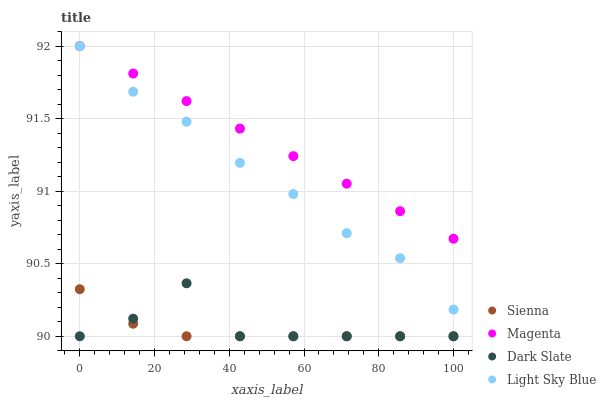Does Sienna have the minimum area under the curve?
Answer yes or no. Yes. Does Magenta have the maximum area under the curve?
Answer yes or no. Yes. Does Dark Slate have the minimum area under the curve?
Answer yes or no. No. Does Dark Slate have the maximum area under the curve?
Answer yes or no. No. Is Magenta the smoothest?
Answer yes or no. Yes. Is Dark Slate the roughest?
Answer yes or no. Yes. Is Dark Slate the smoothest?
Answer yes or no. No. Is Magenta the roughest?
Answer yes or no. No. Does Sienna have the lowest value?
Answer yes or no. Yes. Does Magenta have the lowest value?
Answer yes or no. No. Does Light Sky Blue have the highest value?
Answer yes or no. Yes. Does Dark Slate have the highest value?
Answer yes or no. No. Is Dark Slate less than Magenta?
Answer yes or no. Yes. Is Light Sky Blue greater than Dark Slate?
Answer yes or no. Yes. Does Sienna intersect Dark Slate?
Answer yes or no. Yes. Is Sienna less than Dark Slate?
Answer yes or no. No. Is Sienna greater than Dark Slate?
Answer yes or no. No. Does Dark Slate intersect Magenta?
Answer yes or no. No. 